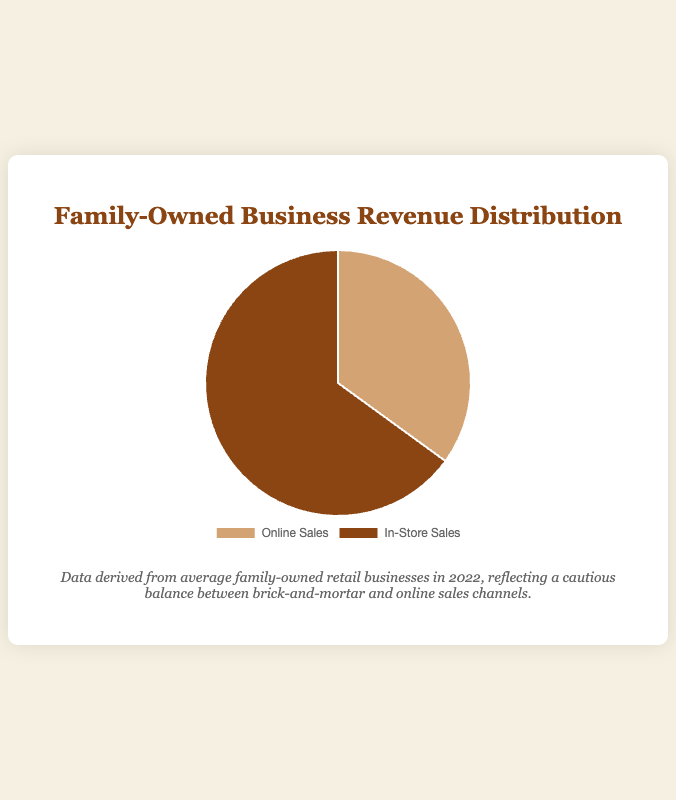What percentage of total revenue comes from in-store sales? In the pie chart, the segment for In-Store Sales is labeled with a percentage. According to the figure, the proportion of revenue from in-store sales is 65%.
Answer: 65% What is the difference between the percentages of online and in-store sales? The pie chart shows that online sales account for 35% and in-store sales for 65%. To find the difference, subtract the smaller percentage from the larger one: 65% - 35% = 30%.
Answer: 30% Which sales channel generates a greater proportion of revenue? The pie chart visually highlights that the In-Store Sales segment is larger than the Online Sales segment. The associated percentages confirm this: 65% for in-store vs. 35% for online.
Answer: In-Store Sales By what factor is the in-store sales revenue larger than the online sales revenue? To determine the factor, divide the percentage of in-store sales by the percentage of online sales: 65% ÷ 35% ≈ 1.86. This means in-store sales revenue is roughly 1.86 times that of online sales.
Answer: 1.86 What are the specific colors representing online and in-store sales in the pie chart? The pie chart uses different colors for each segment. From the chart, the color for Online Sales is brownish (light tan), while In-Store Sales is represented by a darker brown.
Answer: Light tan for Online sales, Dark brown for In-Store sales What proportion of the total revenue comes from channels other than in-store sales? The chart shows two segments: Online Sales and In-Store Sales. The percentage for other channels (if any) would be the remainder of the total 100%. Since there are only two segments and one is for in-store sales at 65%, the other channels would account for 35%.
Answer: 35% If the total revenue is $1,000,000, how much revenue is generated from online sales? The pie chart shows 35% of the revenue comes from online sales. To find the specific amount: $1,000,000 * 35% = $1,000,000 * 0.35 = $350,000.
Answer: $350,000 How much more revenue does in-store sales generate compared to online sales if the total revenue is $1,000,000? First, calculate the revenue from each channel: Online Sales = $1,000,000 * 0.35 = $350,000; In-Store Sales = $1,000,000 * 0.65 = $650,000. The difference is $650,000 - $350,000 = $300,000.
Answer: $300,000 